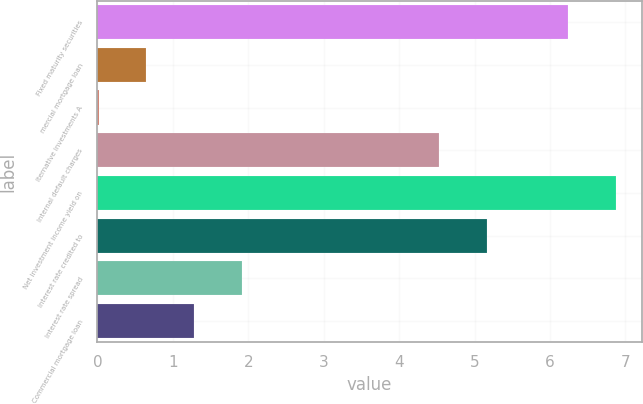Convert chart to OTSL. <chart><loc_0><loc_0><loc_500><loc_500><bar_chart><fcel>Fixed maturity securities<fcel>mercial mortgage loan<fcel>lternative investments A<fcel>Internal default charges<fcel>Net investment income yield on<fcel>Interest rate credited to<fcel>Interest rate spread<fcel>Commercial mortgage loan<nl><fcel>6.24<fcel>0.65<fcel>0.02<fcel>4.53<fcel>6.87<fcel>5.16<fcel>1.91<fcel>1.28<nl></chart> 